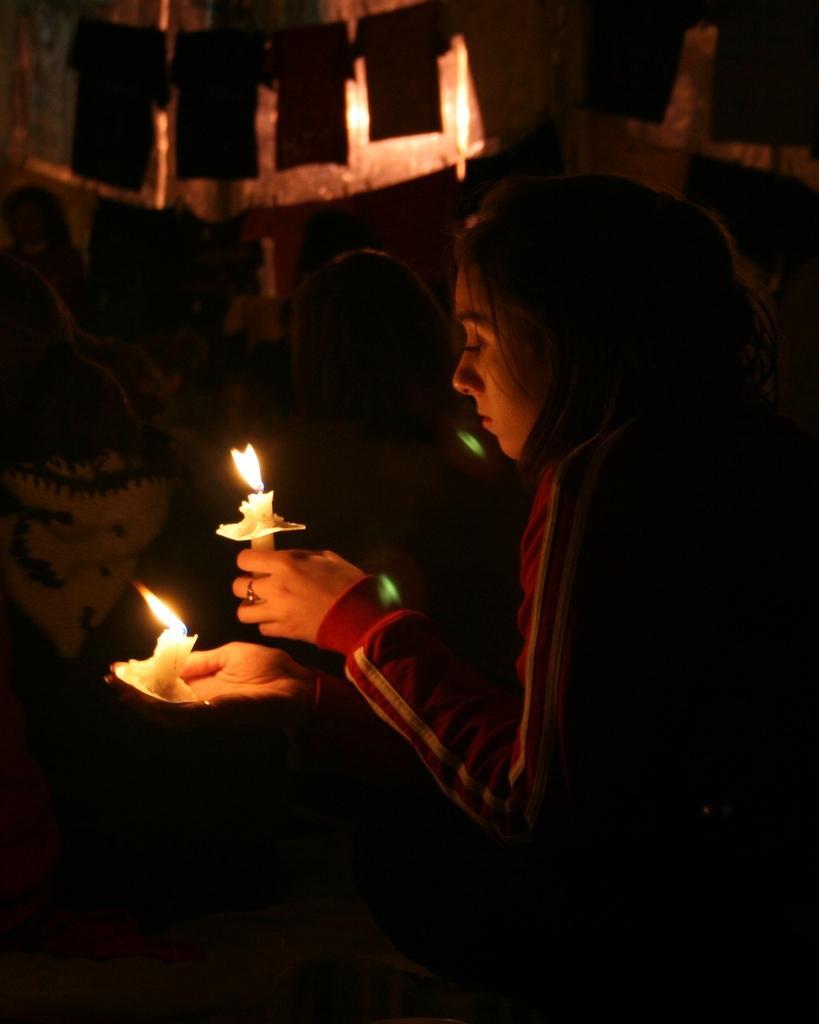Could you give a brief overview of what you see in this image? In this image there are people standing and a woman is holding candles in her hand. 